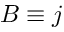<formula> <loc_0><loc_0><loc_500><loc_500>B \equiv j</formula> 